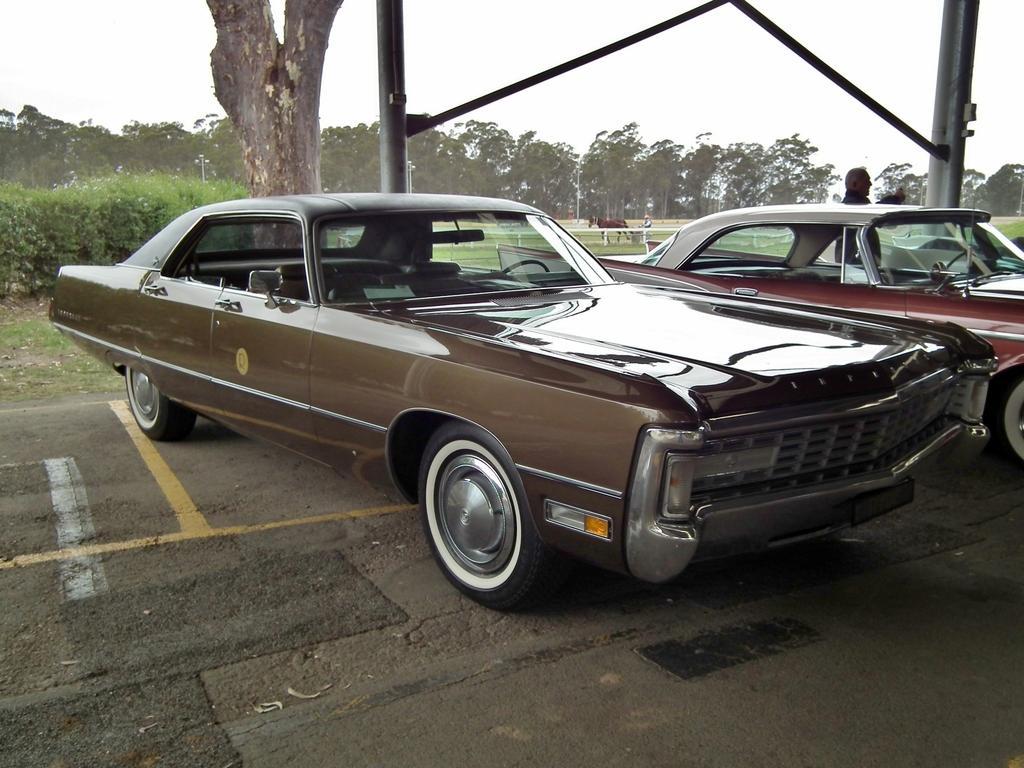Can you describe this image briefly? In this image there are two cars on the road. Beside the car there is a person and at the back side there is a horse and trees. 